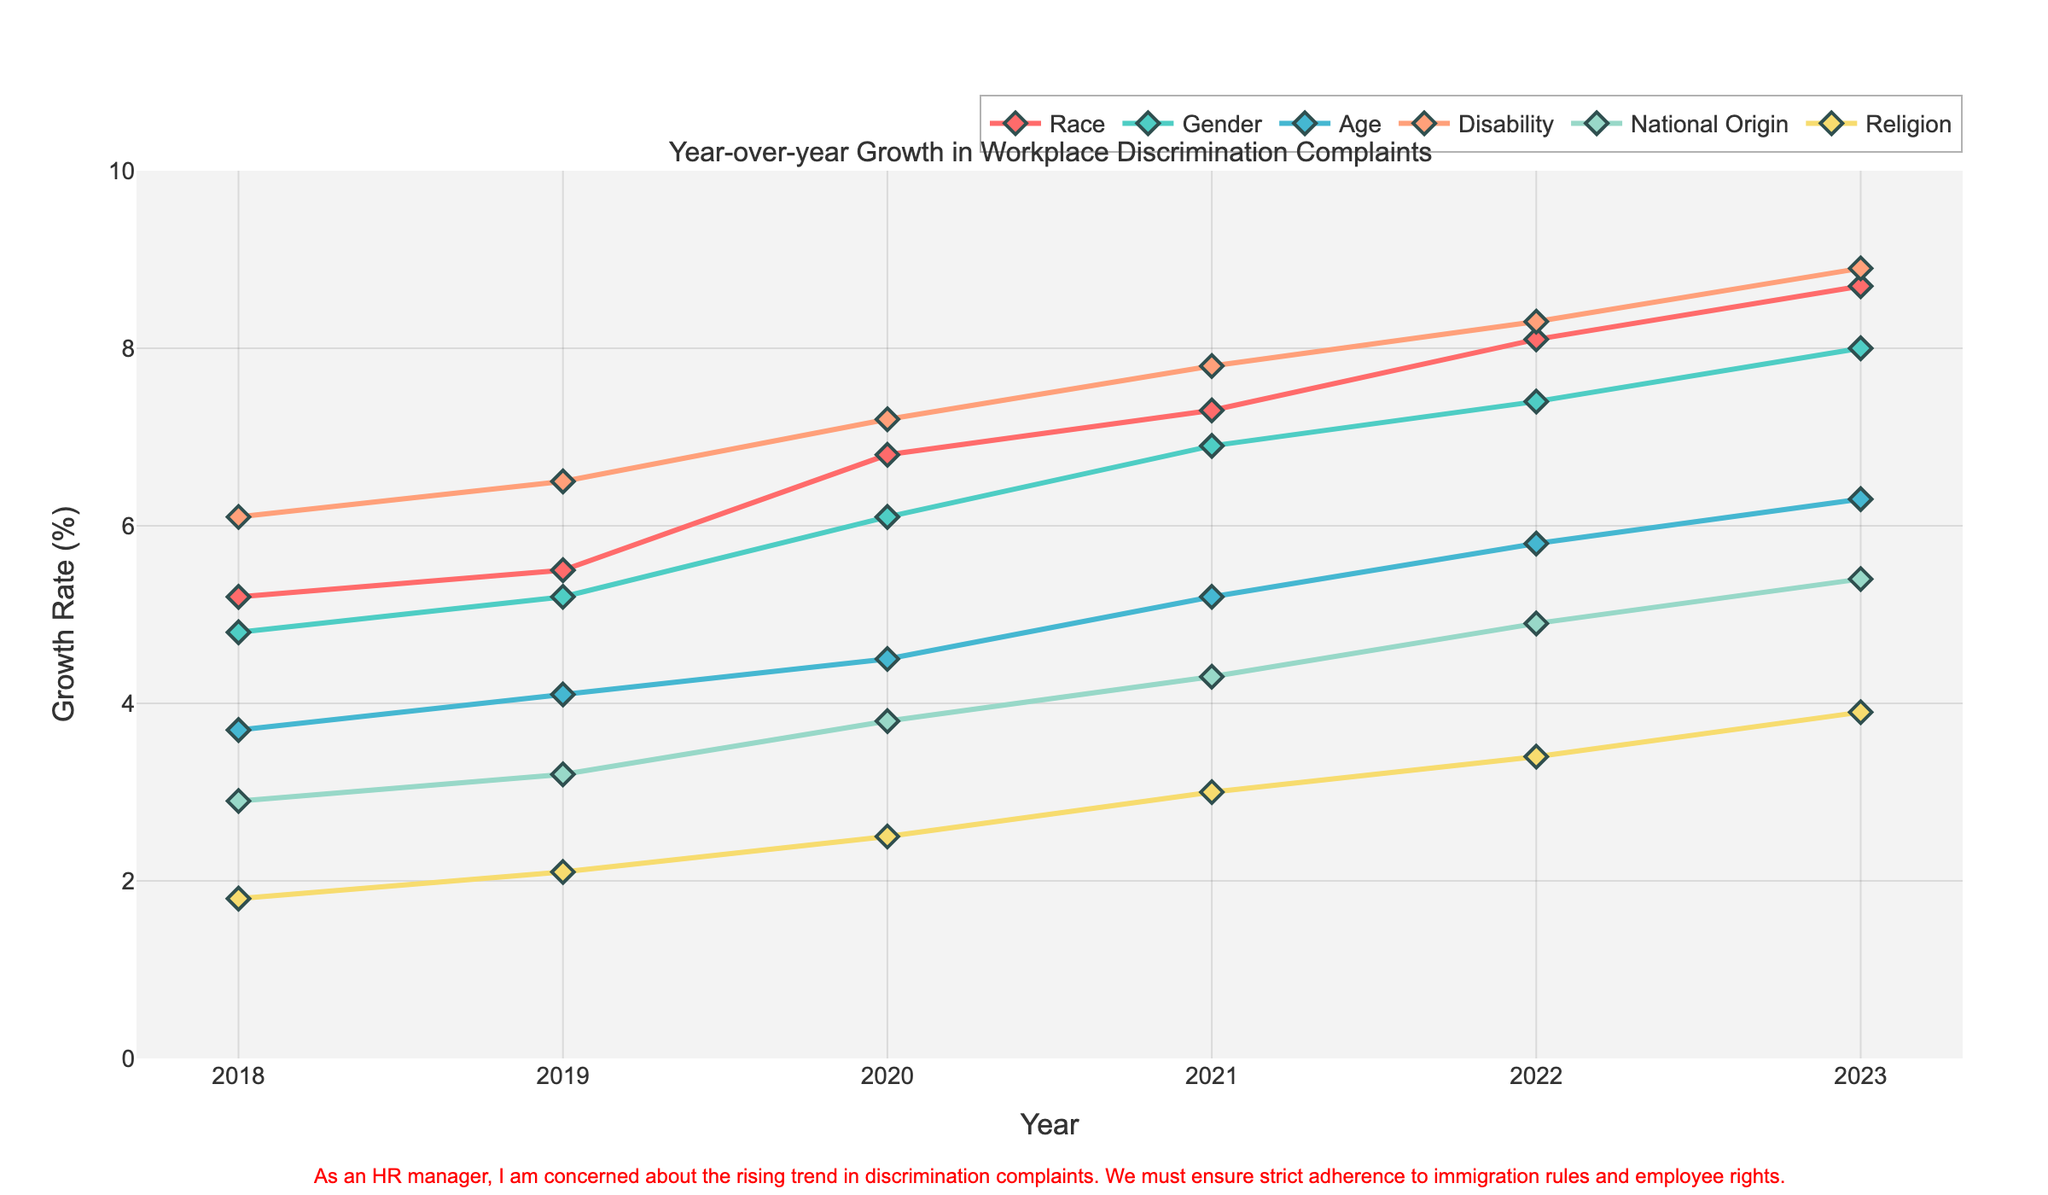What protected characteristic had the highest growth rate in 2023? By examining the figure, the line representing each characteristic can be checked for its highest point in 2023. The one with the highest growth rate is 'Race'.
Answer: Race Which protected characteristic showed the lowest growth rate in 2018? To determine this, look for the point closest to the bottom of the y-axis in 2018. 'Religion' has the lowest growth rate of 1.8% in 2018.
Answer: Religion What is the difference in the growth rate of workplace discrimination complaints related to gender from 2018 to 2023? In 2018, the growth rate for gender was 4.8%, and in 2023, it was 8.0%. The difference is calculated as 8.0% - 4.8% = 3.2%.
Answer: 3.2% Between 2018 and 2023, did any characteristic show a constant increase every year? By visually inspecting the lines, 'Race', 'Gender', 'Age', 'Disability', 'National Origin', and 'Religion' all show a consistently increasing trend every year without any dips.
Answer: Yes Which protected characteristic had the smallest increase in growth rate between 2019 and 2020? Checking the slopes of the lines between these years, 'Religion' had the smallest increase from 2.1% to 2.5%, which is a difference of only 0.4%.
Answer: Religion How many characteristics had a growth rate above 7% in 2022? To answer this, identify the lines that lie above the 7% mark on the y-axis for the year 2022. They are 'Race', 'Gender', and 'Disability'.
Answer: 3 What was the approximate average growth rate of complaints in 2021 across all characteristics? Sum the rates for each characteristic in 2021: (7.3 + 6.9 + 5.2 + 7.8 + 4.3 + 3.0) = 34.5, then divide by the number of characteristics, which is 6. The average is 34.5 / 6 ≈ 5.75%.
Answer: 5.75% Compare the growth rates of complaints due to National Origin and Disability in 2023. Which one is higher and by how much? The growth rate for Disability in 2023 is 8.9% and for National Origin is 5.4%. The difference is 8.9% - 5.4% = 3.5%.
Answer: Disability, by 3.5% Did the growth rate for discrimination complaints based on Age ever surpass the growth rate for Religion? Reviewing the lines, the growth rate for Age (3.7% in 2018) is consistently higher than Religion (1.8% in 2018) throughout all years, making the answer affirmative.
Answer: Yes Which characteristic showed the steepest increase in growth rate between 2021 and 2022? The change in the slope for each characteristic between 2021 and 2022 needs to be examined. 'National Origin' went from 4.3% to 4.9%, showing the steepest increase relative to its previous values.
Answer: National Origin 